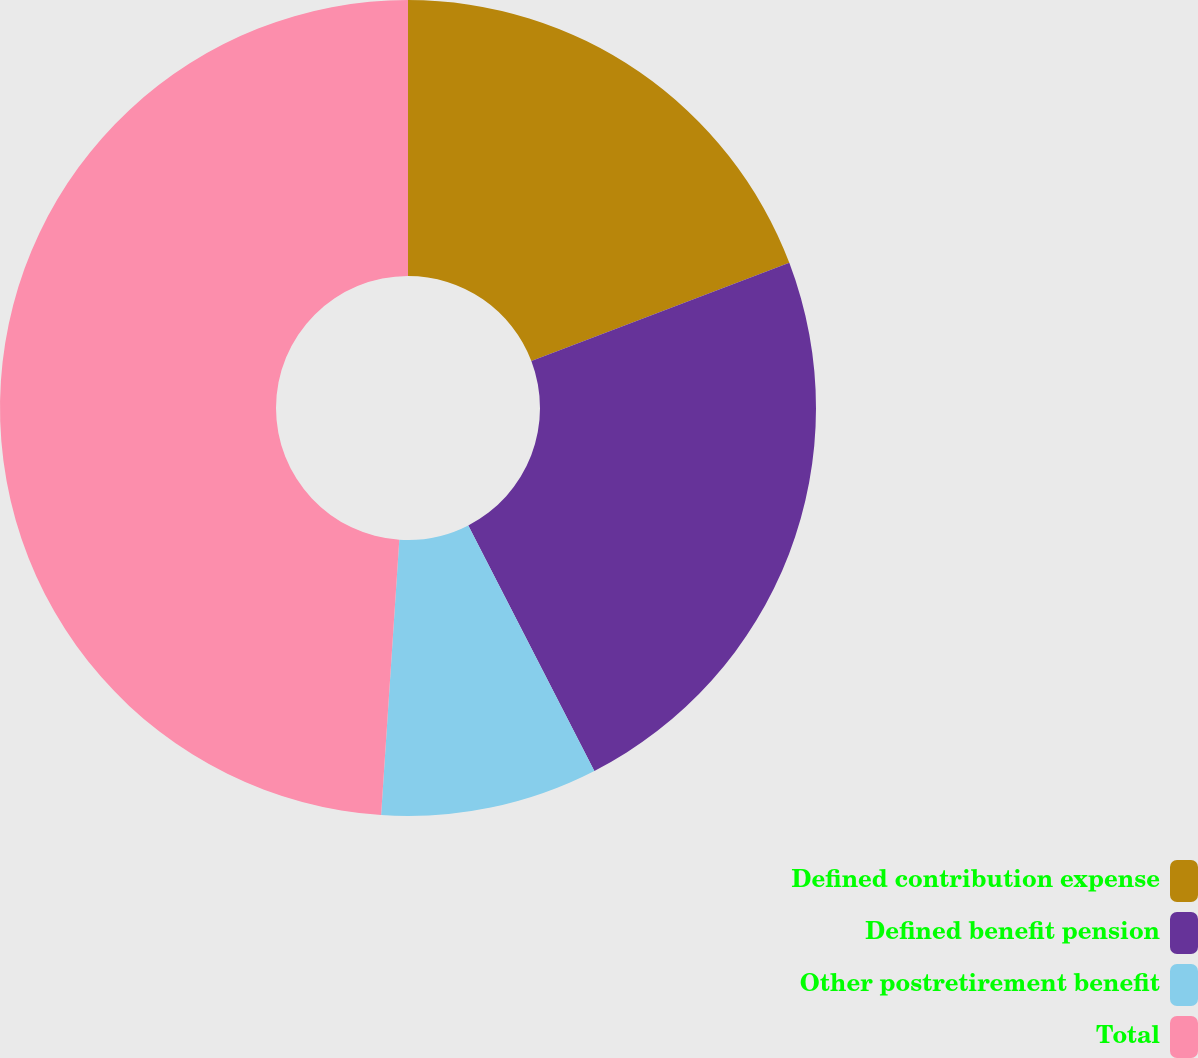<chart> <loc_0><loc_0><loc_500><loc_500><pie_chart><fcel>Defined contribution expense<fcel>Defined benefit pension<fcel>Other postretirement benefit<fcel>Total<nl><fcel>19.21%<fcel>23.24%<fcel>8.6%<fcel>48.95%<nl></chart> 